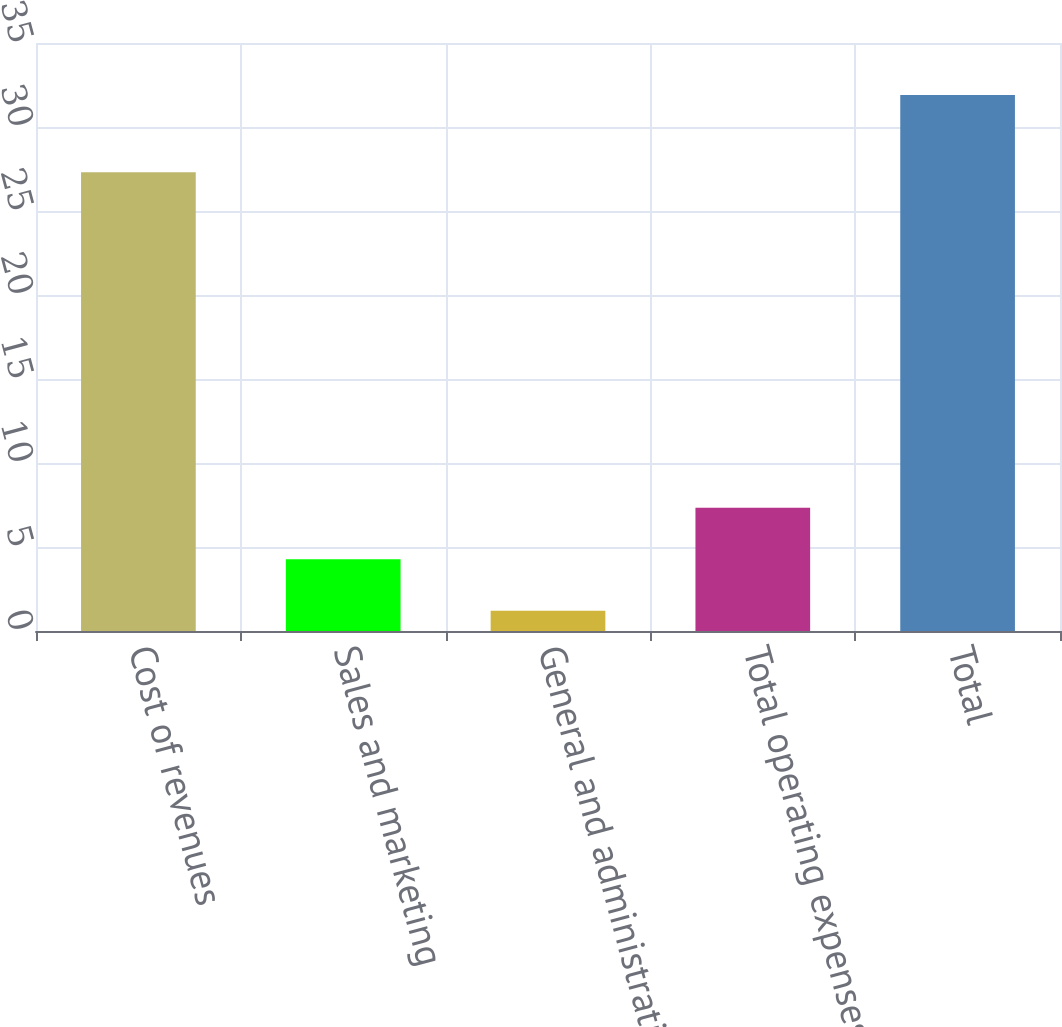Convert chart. <chart><loc_0><loc_0><loc_500><loc_500><bar_chart><fcel>Cost of revenues<fcel>Sales and marketing<fcel>General and administrative<fcel>Total operating expenses<fcel>Total<nl><fcel>27.3<fcel>4.27<fcel>1.2<fcel>7.34<fcel>31.9<nl></chart> 